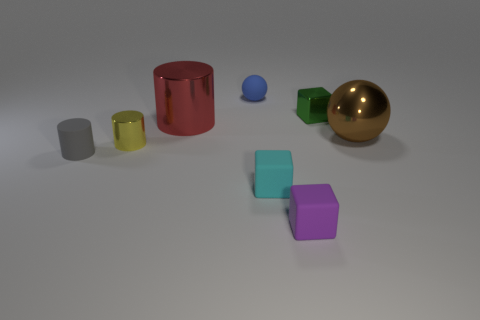Add 1 small blue cylinders. How many objects exist? 9 Subtract all balls. How many objects are left? 6 Add 1 brown objects. How many brown objects exist? 2 Subtract 0 blue cubes. How many objects are left? 8 Subtract all tiny blue matte objects. Subtract all tiny gray matte cylinders. How many objects are left? 6 Add 5 yellow cylinders. How many yellow cylinders are left? 6 